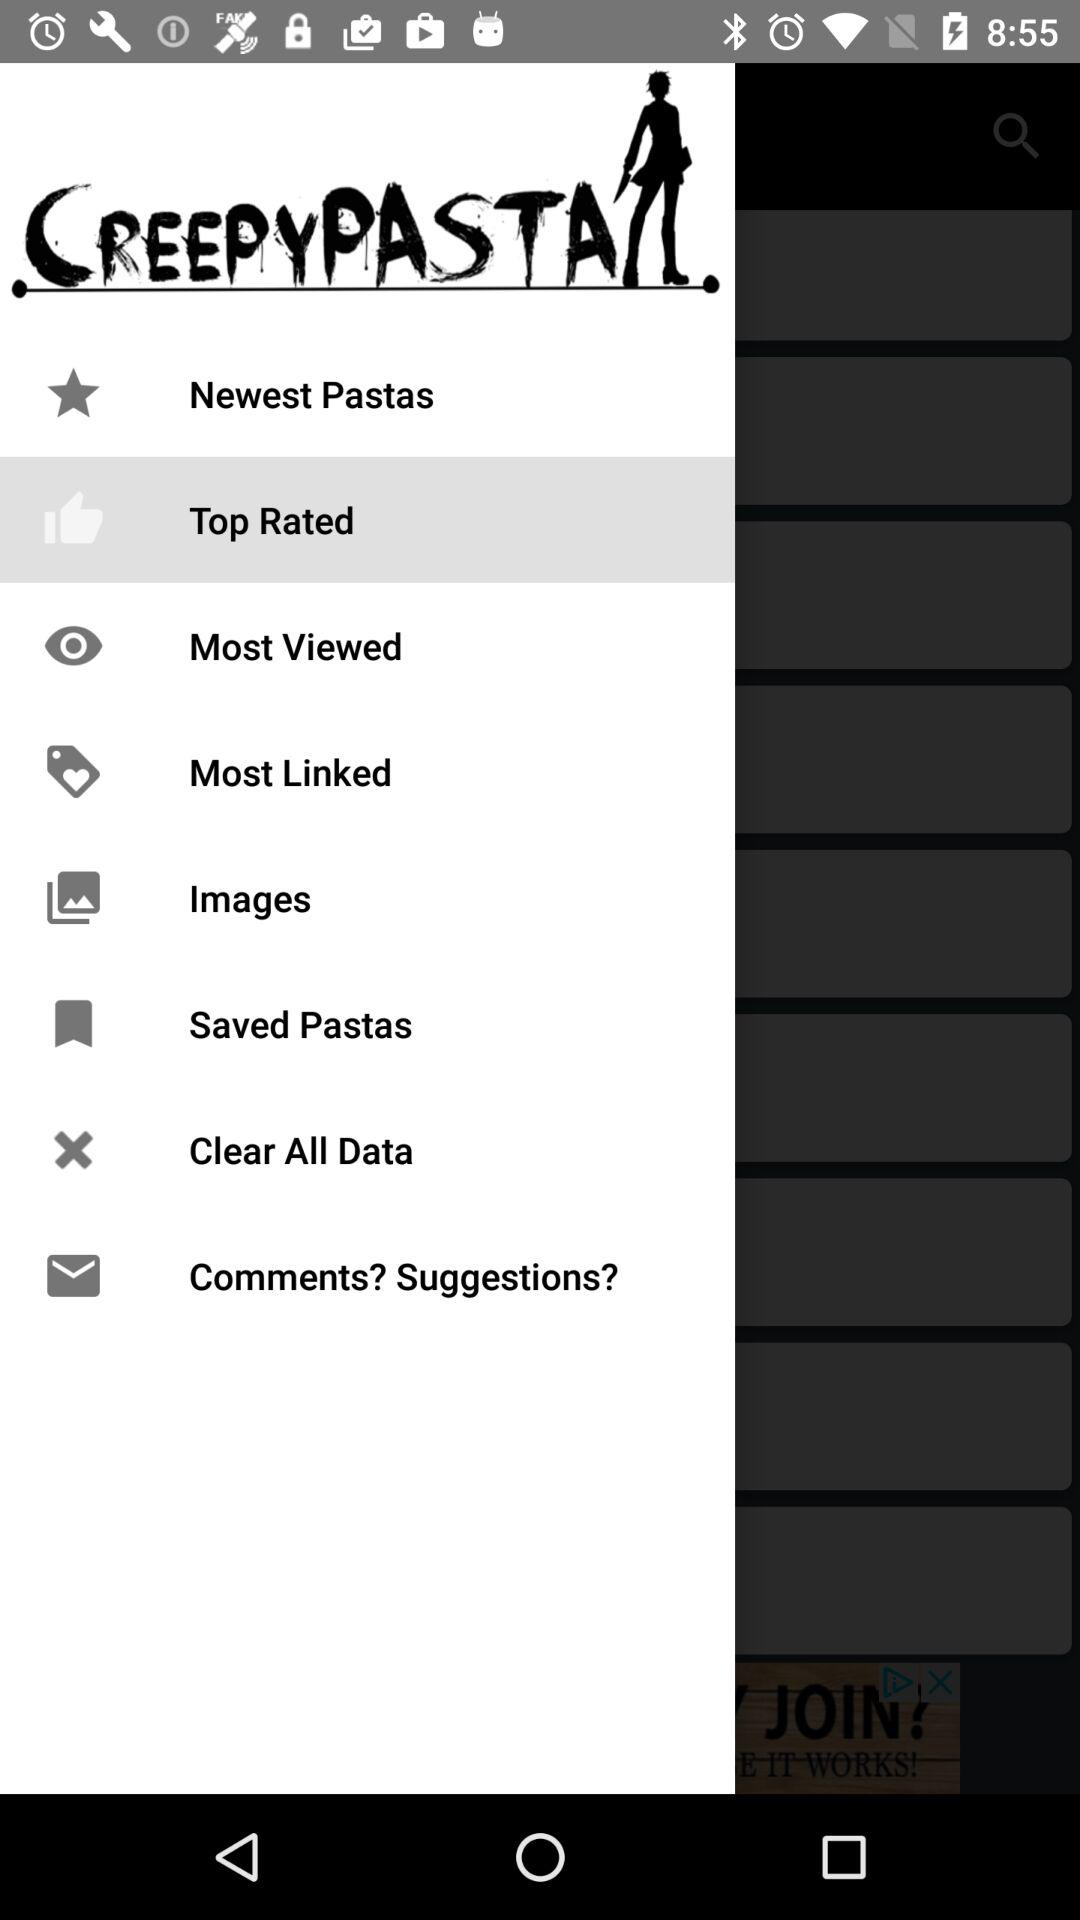Which images are the most viewed?
When the provided information is insufficient, respond with <no answer>. <no answer> 